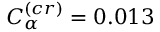<formula> <loc_0><loc_0><loc_500><loc_500>C _ { \alpha } ^ { ( c r ) } = 0 . 0 1 3</formula> 